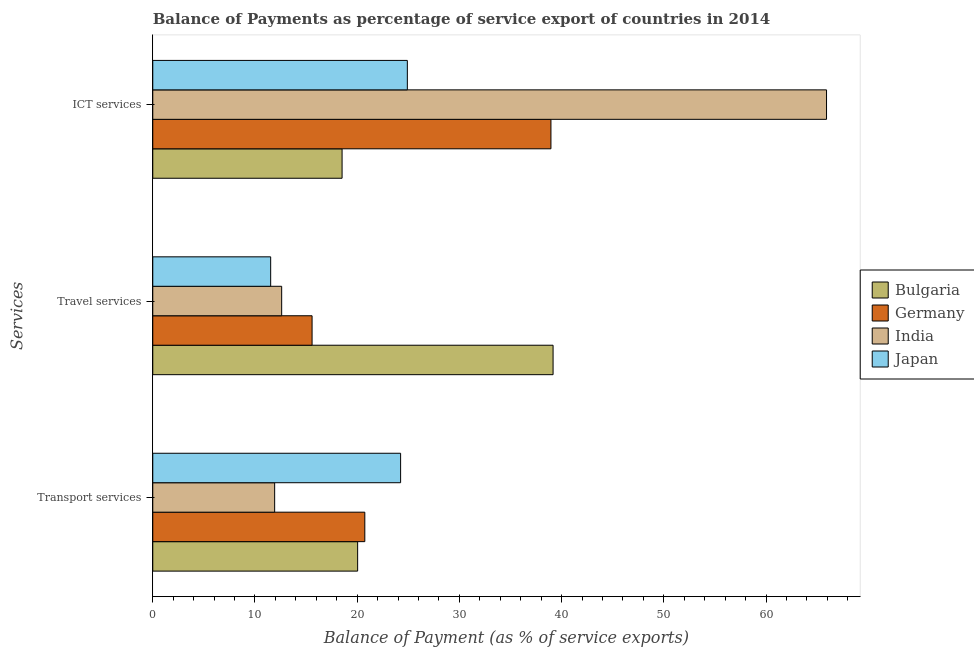How many groups of bars are there?
Offer a very short reply. 3. Are the number of bars per tick equal to the number of legend labels?
Give a very brief answer. Yes. What is the label of the 1st group of bars from the top?
Offer a terse response. ICT services. What is the balance of payment of ict services in Japan?
Offer a terse response. 24.91. Across all countries, what is the maximum balance of payment of transport services?
Your answer should be very brief. 24.25. Across all countries, what is the minimum balance of payment of ict services?
Provide a short and direct response. 18.52. In which country was the balance of payment of transport services maximum?
Give a very brief answer. Japan. What is the total balance of payment of ict services in the graph?
Provide a short and direct response. 148.3. What is the difference between the balance of payment of ict services in Germany and that in India?
Provide a short and direct response. -26.96. What is the difference between the balance of payment of transport services in Bulgaria and the balance of payment of ict services in India?
Provide a succinct answer. -45.87. What is the average balance of payment of transport services per country?
Your answer should be compact. 19.24. What is the difference between the balance of payment of ict services and balance of payment of transport services in India?
Give a very brief answer. 53.99. What is the ratio of the balance of payment of transport services in India to that in Germany?
Your response must be concise. 0.57. Is the balance of payment of transport services in Bulgaria less than that in Germany?
Provide a short and direct response. Yes. Is the difference between the balance of payment of travel services in India and Bulgaria greater than the difference between the balance of payment of ict services in India and Bulgaria?
Keep it short and to the point. No. What is the difference between the highest and the second highest balance of payment of ict services?
Provide a short and direct response. 26.96. What is the difference between the highest and the lowest balance of payment of ict services?
Provide a short and direct response. 47.4. Is the sum of the balance of payment of transport services in India and Germany greater than the maximum balance of payment of ict services across all countries?
Offer a very short reply. No. What does the 4th bar from the top in Transport services represents?
Keep it short and to the point. Bulgaria. What does the 1st bar from the bottom in ICT services represents?
Make the answer very short. Bulgaria. How many bars are there?
Your response must be concise. 12. Are all the bars in the graph horizontal?
Your answer should be compact. Yes. How many countries are there in the graph?
Keep it short and to the point. 4. How many legend labels are there?
Your answer should be compact. 4. What is the title of the graph?
Provide a short and direct response. Balance of Payments as percentage of service export of countries in 2014. Does "Bosnia and Herzegovina" appear as one of the legend labels in the graph?
Give a very brief answer. No. What is the label or title of the X-axis?
Your response must be concise. Balance of Payment (as % of service exports). What is the label or title of the Y-axis?
Ensure brevity in your answer.  Services. What is the Balance of Payment (as % of service exports) in Bulgaria in Transport services?
Provide a short and direct response. 20.04. What is the Balance of Payment (as % of service exports) of Germany in Transport services?
Ensure brevity in your answer.  20.75. What is the Balance of Payment (as % of service exports) of India in Transport services?
Your answer should be compact. 11.92. What is the Balance of Payment (as % of service exports) in Japan in Transport services?
Offer a very short reply. 24.25. What is the Balance of Payment (as % of service exports) of Bulgaria in Travel services?
Make the answer very short. 39.17. What is the Balance of Payment (as % of service exports) of Germany in Travel services?
Ensure brevity in your answer.  15.59. What is the Balance of Payment (as % of service exports) of India in Travel services?
Offer a very short reply. 12.61. What is the Balance of Payment (as % of service exports) of Japan in Travel services?
Offer a very short reply. 11.54. What is the Balance of Payment (as % of service exports) of Bulgaria in ICT services?
Provide a succinct answer. 18.52. What is the Balance of Payment (as % of service exports) of Germany in ICT services?
Your response must be concise. 38.96. What is the Balance of Payment (as % of service exports) of India in ICT services?
Offer a very short reply. 65.92. What is the Balance of Payment (as % of service exports) of Japan in ICT services?
Your answer should be compact. 24.91. Across all Services, what is the maximum Balance of Payment (as % of service exports) in Bulgaria?
Offer a terse response. 39.17. Across all Services, what is the maximum Balance of Payment (as % of service exports) of Germany?
Your answer should be very brief. 38.96. Across all Services, what is the maximum Balance of Payment (as % of service exports) in India?
Make the answer very short. 65.92. Across all Services, what is the maximum Balance of Payment (as % of service exports) of Japan?
Your answer should be compact. 24.91. Across all Services, what is the minimum Balance of Payment (as % of service exports) in Bulgaria?
Make the answer very short. 18.52. Across all Services, what is the minimum Balance of Payment (as % of service exports) in Germany?
Make the answer very short. 15.59. Across all Services, what is the minimum Balance of Payment (as % of service exports) of India?
Your answer should be compact. 11.92. Across all Services, what is the minimum Balance of Payment (as % of service exports) in Japan?
Ensure brevity in your answer.  11.54. What is the total Balance of Payment (as % of service exports) in Bulgaria in the graph?
Keep it short and to the point. 77.73. What is the total Balance of Payment (as % of service exports) of Germany in the graph?
Keep it short and to the point. 75.29. What is the total Balance of Payment (as % of service exports) of India in the graph?
Your response must be concise. 90.45. What is the total Balance of Payment (as % of service exports) of Japan in the graph?
Give a very brief answer. 60.69. What is the difference between the Balance of Payment (as % of service exports) in Bulgaria in Transport services and that in Travel services?
Give a very brief answer. -19.12. What is the difference between the Balance of Payment (as % of service exports) in Germany in Transport services and that in Travel services?
Offer a very short reply. 5.16. What is the difference between the Balance of Payment (as % of service exports) in India in Transport services and that in Travel services?
Provide a short and direct response. -0.69. What is the difference between the Balance of Payment (as % of service exports) of Japan in Transport services and that in Travel services?
Give a very brief answer. 12.71. What is the difference between the Balance of Payment (as % of service exports) in Bulgaria in Transport services and that in ICT services?
Ensure brevity in your answer.  1.52. What is the difference between the Balance of Payment (as % of service exports) in Germany in Transport services and that in ICT services?
Give a very brief answer. -18.21. What is the difference between the Balance of Payment (as % of service exports) of India in Transport services and that in ICT services?
Your response must be concise. -53.99. What is the difference between the Balance of Payment (as % of service exports) of Japan in Transport services and that in ICT services?
Make the answer very short. -0.66. What is the difference between the Balance of Payment (as % of service exports) of Bulgaria in Travel services and that in ICT services?
Offer a terse response. 20.64. What is the difference between the Balance of Payment (as % of service exports) in Germany in Travel services and that in ICT services?
Your answer should be very brief. -23.37. What is the difference between the Balance of Payment (as % of service exports) in India in Travel services and that in ICT services?
Provide a short and direct response. -53.31. What is the difference between the Balance of Payment (as % of service exports) of Japan in Travel services and that in ICT services?
Your response must be concise. -13.37. What is the difference between the Balance of Payment (as % of service exports) in Bulgaria in Transport services and the Balance of Payment (as % of service exports) in Germany in Travel services?
Offer a terse response. 4.46. What is the difference between the Balance of Payment (as % of service exports) of Bulgaria in Transport services and the Balance of Payment (as % of service exports) of India in Travel services?
Offer a terse response. 7.43. What is the difference between the Balance of Payment (as % of service exports) in Bulgaria in Transport services and the Balance of Payment (as % of service exports) in Japan in Travel services?
Make the answer very short. 8.51. What is the difference between the Balance of Payment (as % of service exports) in Germany in Transport services and the Balance of Payment (as % of service exports) in India in Travel services?
Your answer should be very brief. 8.13. What is the difference between the Balance of Payment (as % of service exports) in Germany in Transport services and the Balance of Payment (as % of service exports) in Japan in Travel services?
Give a very brief answer. 9.21. What is the difference between the Balance of Payment (as % of service exports) in India in Transport services and the Balance of Payment (as % of service exports) in Japan in Travel services?
Offer a terse response. 0.39. What is the difference between the Balance of Payment (as % of service exports) in Bulgaria in Transport services and the Balance of Payment (as % of service exports) in Germany in ICT services?
Give a very brief answer. -18.91. What is the difference between the Balance of Payment (as % of service exports) in Bulgaria in Transport services and the Balance of Payment (as % of service exports) in India in ICT services?
Make the answer very short. -45.87. What is the difference between the Balance of Payment (as % of service exports) in Bulgaria in Transport services and the Balance of Payment (as % of service exports) in Japan in ICT services?
Make the answer very short. -4.86. What is the difference between the Balance of Payment (as % of service exports) of Germany in Transport services and the Balance of Payment (as % of service exports) of India in ICT services?
Make the answer very short. -45.17. What is the difference between the Balance of Payment (as % of service exports) in Germany in Transport services and the Balance of Payment (as % of service exports) in Japan in ICT services?
Provide a short and direct response. -4.16. What is the difference between the Balance of Payment (as % of service exports) of India in Transport services and the Balance of Payment (as % of service exports) of Japan in ICT services?
Keep it short and to the point. -12.98. What is the difference between the Balance of Payment (as % of service exports) in Bulgaria in Travel services and the Balance of Payment (as % of service exports) in Germany in ICT services?
Give a very brief answer. 0.21. What is the difference between the Balance of Payment (as % of service exports) of Bulgaria in Travel services and the Balance of Payment (as % of service exports) of India in ICT services?
Offer a very short reply. -26.75. What is the difference between the Balance of Payment (as % of service exports) in Bulgaria in Travel services and the Balance of Payment (as % of service exports) in Japan in ICT services?
Make the answer very short. 14.26. What is the difference between the Balance of Payment (as % of service exports) in Germany in Travel services and the Balance of Payment (as % of service exports) in India in ICT services?
Provide a succinct answer. -50.33. What is the difference between the Balance of Payment (as % of service exports) in Germany in Travel services and the Balance of Payment (as % of service exports) in Japan in ICT services?
Offer a terse response. -9.32. What is the difference between the Balance of Payment (as % of service exports) of India in Travel services and the Balance of Payment (as % of service exports) of Japan in ICT services?
Give a very brief answer. -12.3. What is the average Balance of Payment (as % of service exports) in Bulgaria per Services?
Make the answer very short. 25.91. What is the average Balance of Payment (as % of service exports) of Germany per Services?
Your answer should be very brief. 25.1. What is the average Balance of Payment (as % of service exports) of India per Services?
Your response must be concise. 30.15. What is the average Balance of Payment (as % of service exports) in Japan per Services?
Give a very brief answer. 20.23. What is the difference between the Balance of Payment (as % of service exports) of Bulgaria and Balance of Payment (as % of service exports) of Germany in Transport services?
Make the answer very short. -0.7. What is the difference between the Balance of Payment (as % of service exports) of Bulgaria and Balance of Payment (as % of service exports) of India in Transport services?
Your answer should be very brief. 8.12. What is the difference between the Balance of Payment (as % of service exports) of Bulgaria and Balance of Payment (as % of service exports) of Japan in Transport services?
Your answer should be compact. -4.2. What is the difference between the Balance of Payment (as % of service exports) of Germany and Balance of Payment (as % of service exports) of India in Transport services?
Offer a very short reply. 8.82. What is the difference between the Balance of Payment (as % of service exports) of Germany and Balance of Payment (as % of service exports) of Japan in Transport services?
Your answer should be compact. -3.5. What is the difference between the Balance of Payment (as % of service exports) of India and Balance of Payment (as % of service exports) of Japan in Transport services?
Keep it short and to the point. -12.32. What is the difference between the Balance of Payment (as % of service exports) in Bulgaria and Balance of Payment (as % of service exports) in Germany in Travel services?
Your answer should be very brief. 23.58. What is the difference between the Balance of Payment (as % of service exports) of Bulgaria and Balance of Payment (as % of service exports) of India in Travel services?
Offer a terse response. 26.55. What is the difference between the Balance of Payment (as % of service exports) in Bulgaria and Balance of Payment (as % of service exports) in Japan in Travel services?
Provide a succinct answer. 27.63. What is the difference between the Balance of Payment (as % of service exports) of Germany and Balance of Payment (as % of service exports) of India in Travel services?
Give a very brief answer. 2.97. What is the difference between the Balance of Payment (as % of service exports) of Germany and Balance of Payment (as % of service exports) of Japan in Travel services?
Offer a terse response. 4.05. What is the difference between the Balance of Payment (as % of service exports) of India and Balance of Payment (as % of service exports) of Japan in Travel services?
Offer a terse response. 1.08. What is the difference between the Balance of Payment (as % of service exports) in Bulgaria and Balance of Payment (as % of service exports) in Germany in ICT services?
Provide a succinct answer. -20.43. What is the difference between the Balance of Payment (as % of service exports) in Bulgaria and Balance of Payment (as % of service exports) in India in ICT services?
Give a very brief answer. -47.4. What is the difference between the Balance of Payment (as % of service exports) of Bulgaria and Balance of Payment (as % of service exports) of Japan in ICT services?
Your answer should be very brief. -6.39. What is the difference between the Balance of Payment (as % of service exports) of Germany and Balance of Payment (as % of service exports) of India in ICT services?
Give a very brief answer. -26.96. What is the difference between the Balance of Payment (as % of service exports) of Germany and Balance of Payment (as % of service exports) of Japan in ICT services?
Your response must be concise. 14.05. What is the difference between the Balance of Payment (as % of service exports) of India and Balance of Payment (as % of service exports) of Japan in ICT services?
Give a very brief answer. 41.01. What is the ratio of the Balance of Payment (as % of service exports) in Bulgaria in Transport services to that in Travel services?
Give a very brief answer. 0.51. What is the ratio of the Balance of Payment (as % of service exports) in Germany in Transport services to that in Travel services?
Provide a succinct answer. 1.33. What is the ratio of the Balance of Payment (as % of service exports) in India in Transport services to that in Travel services?
Ensure brevity in your answer.  0.95. What is the ratio of the Balance of Payment (as % of service exports) in Japan in Transport services to that in Travel services?
Keep it short and to the point. 2.1. What is the ratio of the Balance of Payment (as % of service exports) in Bulgaria in Transport services to that in ICT services?
Provide a succinct answer. 1.08. What is the ratio of the Balance of Payment (as % of service exports) of Germany in Transport services to that in ICT services?
Keep it short and to the point. 0.53. What is the ratio of the Balance of Payment (as % of service exports) in India in Transport services to that in ICT services?
Your response must be concise. 0.18. What is the ratio of the Balance of Payment (as % of service exports) in Japan in Transport services to that in ICT services?
Offer a very short reply. 0.97. What is the ratio of the Balance of Payment (as % of service exports) in Bulgaria in Travel services to that in ICT services?
Ensure brevity in your answer.  2.11. What is the ratio of the Balance of Payment (as % of service exports) in Germany in Travel services to that in ICT services?
Provide a succinct answer. 0.4. What is the ratio of the Balance of Payment (as % of service exports) of India in Travel services to that in ICT services?
Offer a terse response. 0.19. What is the ratio of the Balance of Payment (as % of service exports) in Japan in Travel services to that in ICT services?
Provide a succinct answer. 0.46. What is the difference between the highest and the second highest Balance of Payment (as % of service exports) in Bulgaria?
Give a very brief answer. 19.12. What is the difference between the highest and the second highest Balance of Payment (as % of service exports) of Germany?
Provide a succinct answer. 18.21. What is the difference between the highest and the second highest Balance of Payment (as % of service exports) of India?
Keep it short and to the point. 53.31. What is the difference between the highest and the second highest Balance of Payment (as % of service exports) of Japan?
Ensure brevity in your answer.  0.66. What is the difference between the highest and the lowest Balance of Payment (as % of service exports) of Bulgaria?
Offer a very short reply. 20.64. What is the difference between the highest and the lowest Balance of Payment (as % of service exports) of Germany?
Your answer should be compact. 23.37. What is the difference between the highest and the lowest Balance of Payment (as % of service exports) in India?
Offer a very short reply. 53.99. What is the difference between the highest and the lowest Balance of Payment (as % of service exports) of Japan?
Provide a succinct answer. 13.37. 